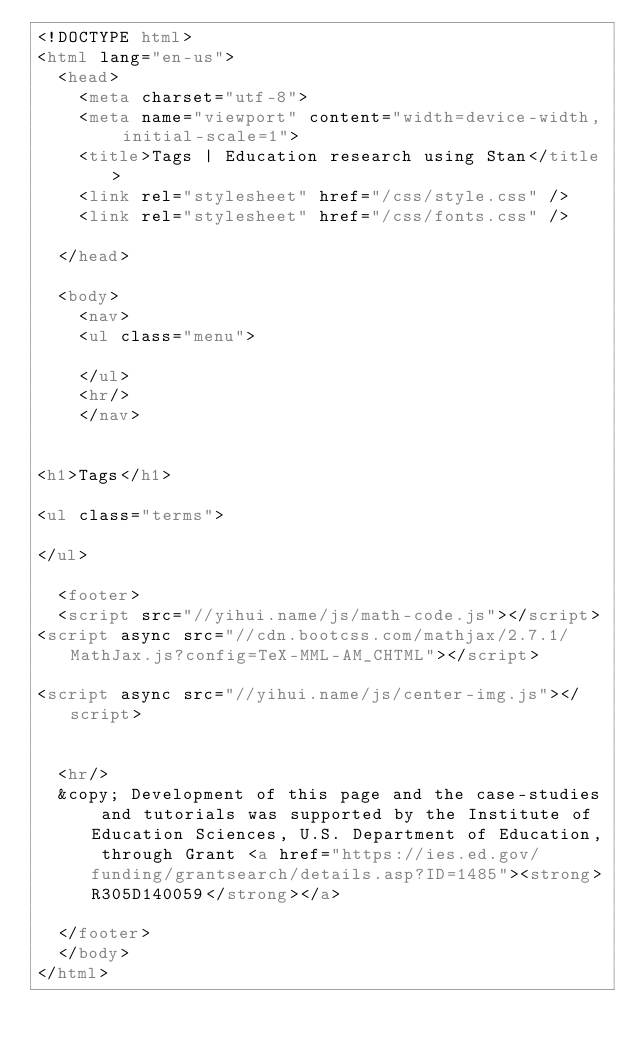Convert code to text. <code><loc_0><loc_0><loc_500><loc_500><_HTML_><!DOCTYPE html>
<html lang="en-us">
  <head>
    <meta charset="utf-8">
    <meta name="viewport" content="width=device-width, initial-scale=1">
    <title>Tags | Education research using Stan</title>
    <link rel="stylesheet" href="/css/style.css" />
    <link rel="stylesheet" href="/css/fonts.css" />
    
  </head>

  <body>
    <nav>
    <ul class="menu">
      
    </ul>
    <hr/>
    </nav>


<h1>Tags</h1>

<ul class="terms">
  
</ul>

  <footer>
  <script src="//yihui.name/js/math-code.js"></script>
<script async src="//cdn.bootcss.com/mathjax/2.7.1/MathJax.js?config=TeX-MML-AM_CHTML"></script>

<script async src="//yihui.name/js/center-img.js"></script>

  
  <hr/>
  &copy; Development of this page and the case-studies and tutorials was supported by the Institute of Education Sciences, U.S. Department of Education, through Grant <a href="https://ies.ed.gov/funding/grantsearch/details.asp?ID=1485"><strong>R305D140059</strong></a>
  
  </footer>
  </body>
</html>

</code> 